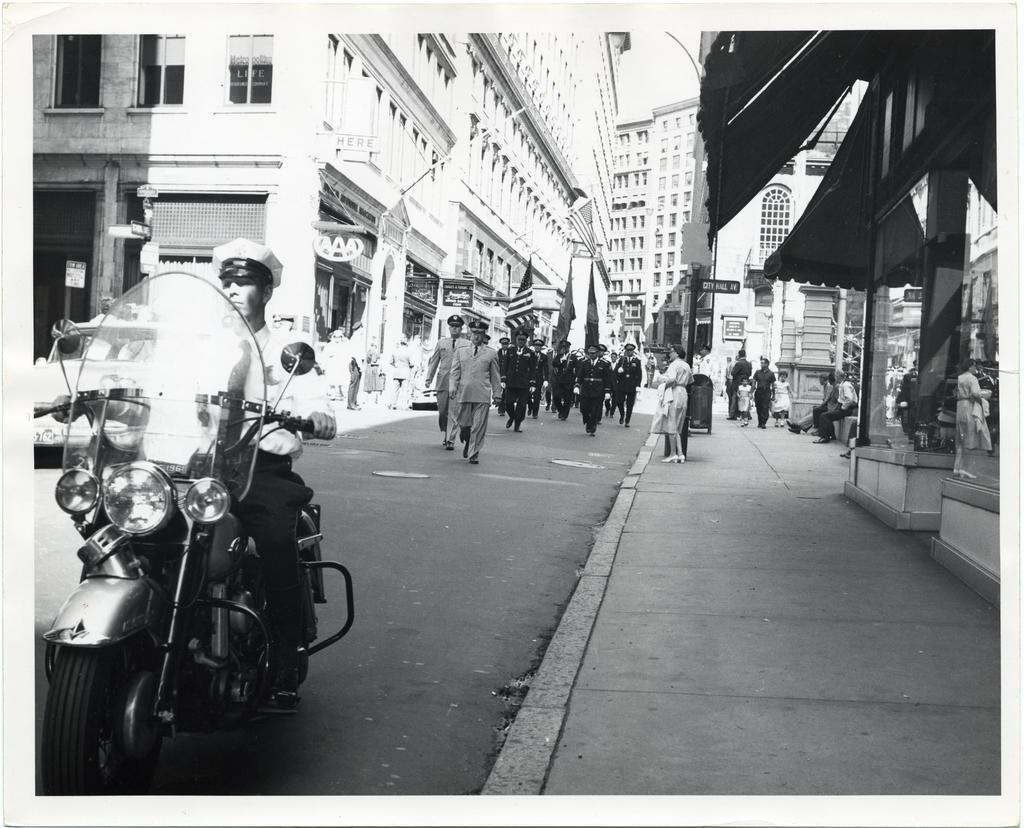Can you describe this image briefly? As we can see in the image, there are buildings, a motorcycle and few people walking on road. 